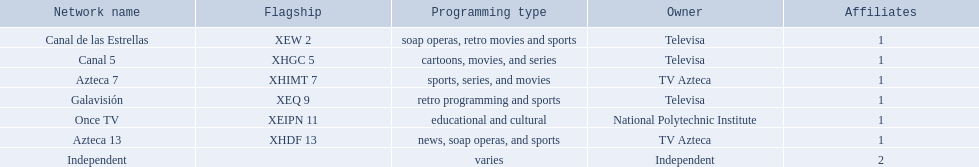What are each of the networks? Canal de las Estrellas, Canal 5, Azteca 7, Galavisión, Once TV, Azteca 13, Independent. Who owns them? Televisa, Televisa, TV Azteca, Televisa, National Polytechnic Institute, TV Azteca, Independent. Which networks aren't owned by televisa? Azteca 7, Once TV, Azteca 13, Independent. What type of programming do those networks offer? Sports, series, and movies, educational and cultural, news, soap operas, and sports, varies. And which network is the only one with sports? Azteca 7. 